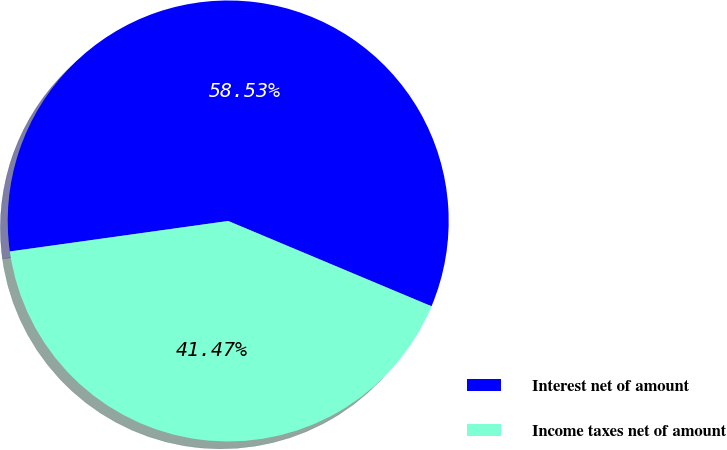<chart> <loc_0><loc_0><loc_500><loc_500><pie_chart><fcel>Interest net of amount<fcel>Income taxes net of amount<nl><fcel>58.53%<fcel>41.47%<nl></chart> 